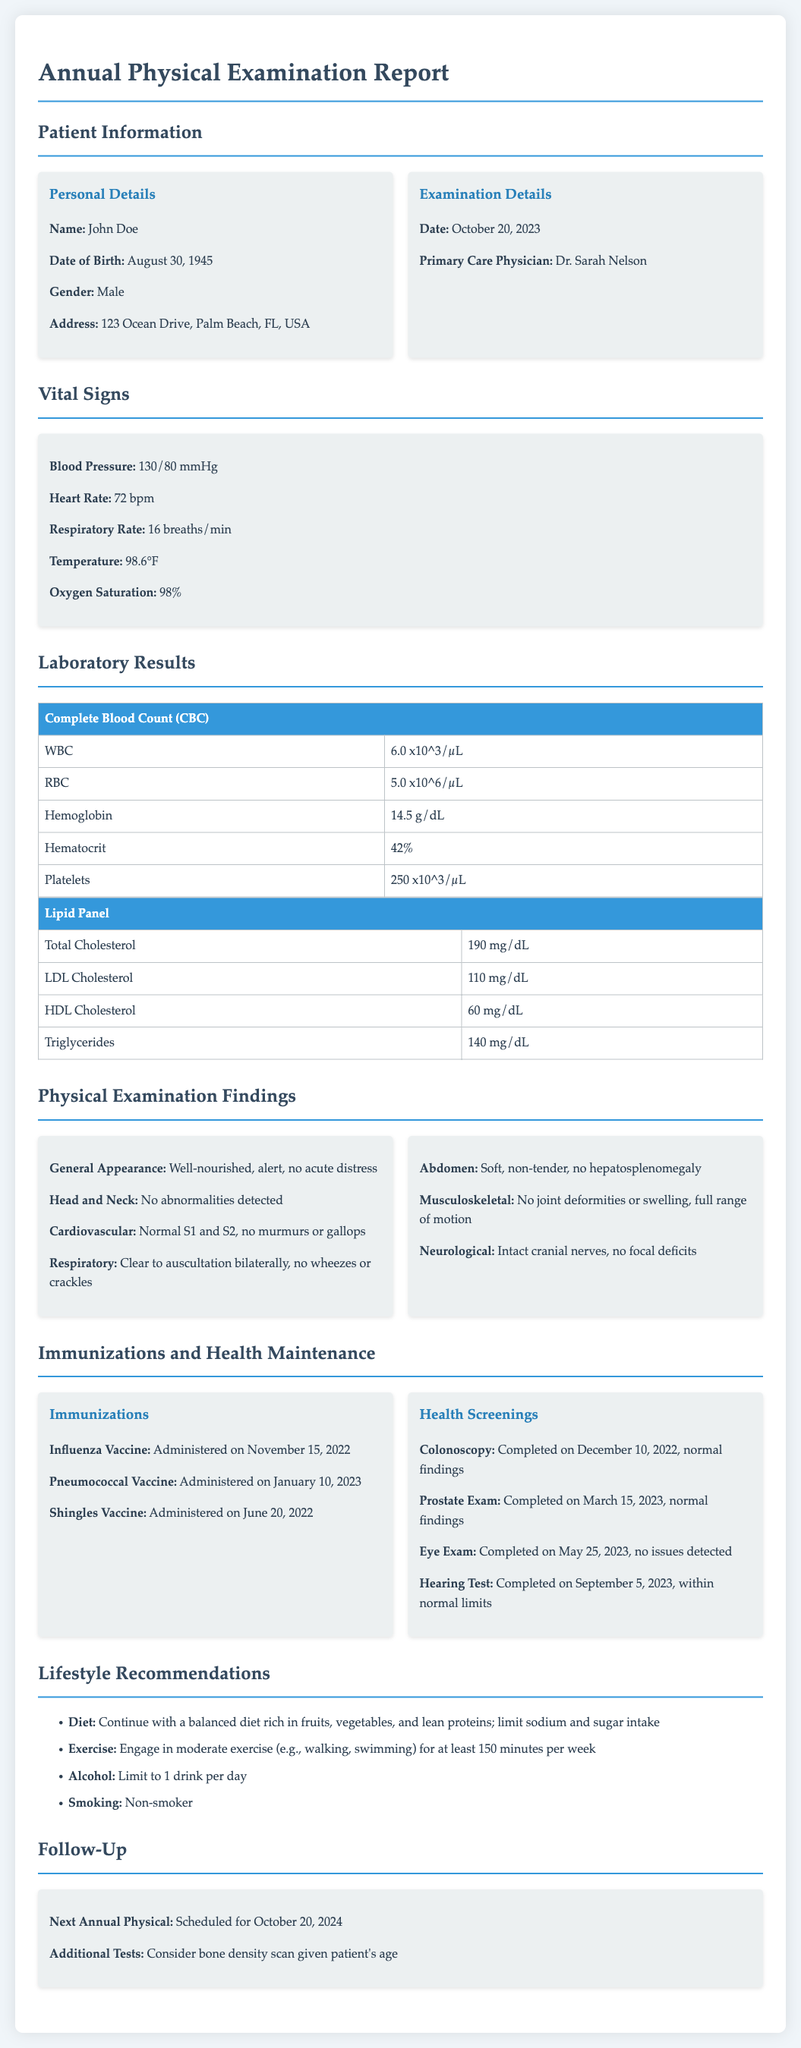what is the patient's name? The patient's name is listed in the personal details section of the document.
Answer: John Doe what is the primary care physician's name? The primary care physician's name is mentioned in the examination details section.
Answer: Dr. Sarah Nelson what was the date of the annual physical examination? The date of the examination is provided in the examination details.
Answer: October 20, 2023 what was the patient's blood pressure reading? The blood pressure is indicated in the vital signs section of the report.
Answer: 130/80 mmHg what is the result of the LDL cholesterol level? The LDL cholesterol level is part of the laboratory results in the document.
Answer: 110 mg/dL what screening was completed on December 10, 2022? The specific screening is mentioned under health screenings in the immunizations and health maintenance section.
Answer: Colonoscopy what lifestyle recommendation is provided regarding exercise? The recommendation regarding exercise is found in the lifestyle recommendations section.
Answer: Engage in moderate exercise (e.g., walking, swimming) for at least 150 minutes per week when is the next annual physical scheduled? The date for the next annual physical can be found in the follow-up section of the document.
Answer: October 20, 2024 what additional test is suggested given the patient's age? The additional test is mentioned in the follow-up section of the report.
Answer: Bone density scan 